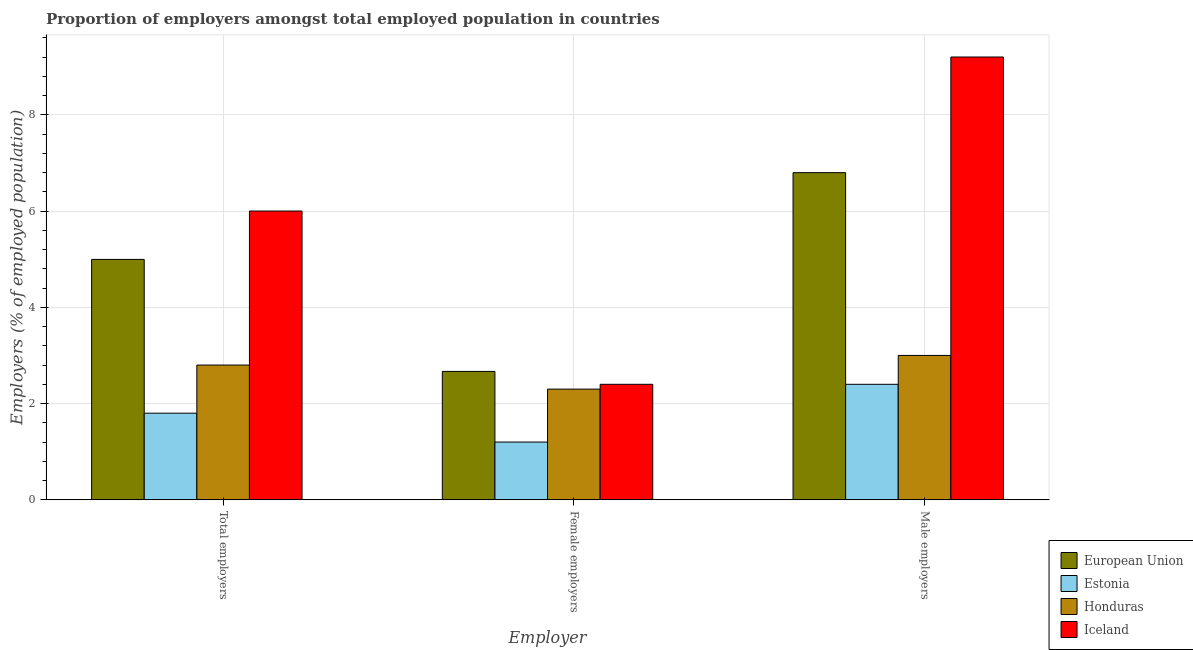How many different coloured bars are there?
Provide a succinct answer. 4. How many groups of bars are there?
Offer a very short reply. 3. How many bars are there on the 3rd tick from the left?
Your answer should be very brief. 4. How many bars are there on the 1st tick from the right?
Provide a succinct answer. 4. What is the label of the 2nd group of bars from the left?
Keep it short and to the point. Female employers. What is the percentage of female employers in Honduras?
Give a very brief answer. 2.3. Across all countries, what is the minimum percentage of female employers?
Keep it short and to the point. 1.2. In which country was the percentage of male employers maximum?
Keep it short and to the point. Iceland. In which country was the percentage of male employers minimum?
Provide a succinct answer. Estonia. What is the total percentage of female employers in the graph?
Your answer should be compact. 8.57. What is the difference between the percentage of male employers in Honduras and that in Iceland?
Offer a terse response. -6.2. What is the difference between the percentage of total employers in European Union and the percentage of female employers in Iceland?
Provide a short and direct response. 2.6. What is the average percentage of male employers per country?
Offer a terse response. 5.35. What is the difference between the percentage of female employers and percentage of male employers in Honduras?
Give a very brief answer. -0.7. In how many countries, is the percentage of total employers greater than 3.6 %?
Your answer should be very brief. 2. What is the ratio of the percentage of total employers in Honduras to that in Iceland?
Offer a terse response. 0.47. Is the difference between the percentage of total employers in Iceland and Estonia greater than the difference between the percentage of female employers in Iceland and Estonia?
Ensure brevity in your answer.  Yes. What is the difference between the highest and the second highest percentage of female employers?
Keep it short and to the point. 0.27. What is the difference between the highest and the lowest percentage of male employers?
Give a very brief answer. 6.8. Is the sum of the percentage of total employers in Iceland and Honduras greater than the maximum percentage of female employers across all countries?
Provide a short and direct response. Yes. What does the 4th bar from the left in Female employers represents?
Make the answer very short. Iceland. Are all the bars in the graph horizontal?
Provide a short and direct response. No. What is the difference between two consecutive major ticks on the Y-axis?
Provide a short and direct response. 2. Does the graph contain any zero values?
Provide a short and direct response. No. Where does the legend appear in the graph?
Your answer should be compact. Bottom right. How many legend labels are there?
Ensure brevity in your answer.  4. How are the legend labels stacked?
Your answer should be compact. Vertical. What is the title of the graph?
Your response must be concise. Proportion of employers amongst total employed population in countries. What is the label or title of the X-axis?
Your answer should be very brief. Employer. What is the label or title of the Y-axis?
Give a very brief answer. Employers (% of employed population). What is the Employers (% of employed population) in European Union in Total employers?
Keep it short and to the point. 5. What is the Employers (% of employed population) in Estonia in Total employers?
Give a very brief answer. 1.8. What is the Employers (% of employed population) in Honduras in Total employers?
Your response must be concise. 2.8. What is the Employers (% of employed population) of European Union in Female employers?
Give a very brief answer. 2.67. What is the Employers (% of employed population) in Estonia in Female employers?
Keep it short and to the point. 1.2. What is the Employers (% of employed population) of Honduras in Female employers?
Offer a very short reply. 2.3. What is the Employers (% of employed population) in Iceland in Female employers?
Your answer should be very brief. 2.4. What is the Employers (% of employed population) of European Union in Male employers?
Make the answer very short. 6.8. What is the Employers (% of employed population) in Estonia in Male employers?
Ensure brevity in your answer.  2.4. What is the Employers (% of employed population) of Honduras in Male employers?
Ensure brevity in your answer.  3. What is the Employers (% of employed population) in Iceland in Male employers?
Your response must be concise. 9.2. Across all Employer, what is the maximum Employers (% of employed population) in European Union?
Provide a succinct answer. 6.8. Across all Employer, what is the maximum Employers (% of employed population) of Estonia?
Provide a short and direct response. 2.4. Across all Employer, what is the maximum Employers (% of employed population) of Honduras?
Provide a succinct answer. 3. Across all Employer, what is the maximum Employers (% of employed population) in Iceland?
Provide a succinct answer. 9.2. Across all Employer, what is the minimum Employers (% of employed population) of European Union?
Offer a terse response. 2.67. Across all Employer, what is the minimum Employers (% of employed population) of Estonia?
Provide a succinct answer. 1.2. Across all Employer, what is the minimum Employers (% of employed population) in Honduras?
Provide a short and direct response. 2.3. Across all Employer, what is the minimum Employers (% of employed population) in Iceland?
Your answer should be very brief. 2.4. What is the total Employers (% of employed population) in European Union in the graph?
Provide a succinct answer. 14.46. What is the total Employers (% of employed population) of Estonia in the graph?
Your response must be concise. 5.4. What is the total Employers (% of employed population) in Honduras in the graph?
Offer a very short reply. 8.1. What is the difference between the Employers (% of employed population) in European Union in Total employers and that in Female employers?
Keep it short and to the point. 2.33. What is the difference between the Employers (% of employed population) in Iceland in Total employers and that in Female employers?
Offer a terse response. 3.6. What is the difference between the Employers (% of employed population) of European Union in Total employers and that in Male employers?
Give a very brief answer. -1.8. What is the difference between the Employers (% of employed population) of Estonia in Total employers and that in Male employers?
Give a very brief answer. -0.6. What is the difference between the Employers (% of employed population) of European Union in Female employers and that in Male employers?
Give a very brief answer. -4.13. What is the difference between the Employers (% of employed population) in Honduras in Female employers and that in Male employers?
Your answer should be compact. -0.7. What is the difference between the Employers (% of employed population) in European Union in Total employers and the Employers (% of employed population) in Estonia in Female employers?
Your answer should be compact. 3.8. What is the difference between the Employers (% of employed population) in European Union in Total employers and the Employers (% of employed population) in Honduras in Female employers?
Ensure brevity in your answer.  2.7. What is the difference between the Employers (% of employed population) in European Union in Total employers and the Employers (% of employed population) in Iceland in Female employers?
Your answer should be very brief. 2.6. What is the difference between the Employers (% of employed population) in Honduras in Total employers and the Employers (% of employed population) in Iceland in Female employers?
Offer a terse response. 0.4. What is the difference between the Employers (% of employed population) of European Union in Total employers and the Employers (% of employed population) of Estonia in Male employers?
Make the answer very short. 2.6. What is the difference between the Employers (% of employed population) of European Union in Total employers and the Employers (% of employed population) of Honduras in Male employers?
Offer a terse response. 2. What is the difference between the Employers (% of employed population) in European Union in Total employers and the Employers (% of employed population) in Iceland in Male employers?
Make the answer very short. -4.2. What is the difference between the Employers (% of employed population) in Estonia in Total employers and the Employers (% of employed population) in Honduras in Male employers?
Your response must be concise. -1.2. What is the difference between the Employers (% of employed population) of European Union in Female employers and the Employers (% of employed population) of Estonia in Male employers?
Make the answer very short. 0.27. What is the difference between the Employers (% of employed population) of European Union in Female employers and the Employers (% of employed population) of Honduras in Male employers?
Your answer should be very brief. -0.33. What is the difference between the Employers (% of employed population) of European Union in Female employers and the Employers (% of employed population) of Iceland in Male employers?
Offer a terse response. -6.53. What is the average Employers (% of employed population) in European Union per Employer?
Offer a very short reply. 4.82. What is the average Employers (% of employed population) of Estonia per Employer?
Make the answer very short. 1.8. What is the average Employers (% of employed population) in Honduras per Employer?
Your answer should be very brief. 2.7. What is the average Employers (% of employed population) of Iceland per Employer?
Provide a succinct answer. 5.87. What is the difference between the Employers (% of employed population) in European Union and Employers (% of employed population) in Estonia in Total employers?
Provide a short and direct response. 3.2. What is the difference between the Employers (% of employed population) of European Union and Employers (% of employed population) of Honduras in Total employers?
Give a very brief answer. 2.2. What is the difference between the Employers (% of employed population) of European Union and Employers (% of employed population) of Iceland in Total employers?
Provide a succinct answer. -1. What is the difference between the Employers (% of employed population) of Estonia and Employers (% of employed population) of Iceland in Total employers?
Offer a very short reply. -4.2. What is the difference between the Employers (% of employed population) in European Union and Employers (% of employed population) in Estonia in Female employers?
Make the answer very short. 1.47. What is the difference between the Employers (% of employed population) of European Union and Employers (% of employed population) of Honduras in Female employers?
Give a very brief answer. 0.37. What is the difference between the Employers (% of employed population) in European Union and Employers (% of employed population) in Iceland in Female employers?
Offer a terse response. 0.27. What is the difference between the Employers (% of employed population) in European Union and Employers (% of employed population) in Estonia in Male employers?
Your answer should be very brief. 4.4. What is the difference between the Employers (% of employed population) in European Union and Employers (% of employed population) in Honduras in Male employers?
Give a very brief answer. 3.8. What is the difference between the Employers (% of employed population) in European Union and Employers (% of employed population) in Iceland in Male employers?
Your response must be concise. -2.4. What is the difference between the Employers (% of employed population) of Estonia and Employers (% of employed population) of Iceland in Male employers?
Keep it short and to the point. -6.8. What is the ratio of the Employers (% of employed population) in European Union in Total employers to that in Female employers?
Your response must be concise. 1.87. What is the ratio of the Employers (% of employed population) in Estonia in Total employers to that in Female employers?
Offer a very short reply. 1.5. What is the ratio of the Employers (% of employed population) of Honduras in Total employers to that in Female employers?
Your answer should be compact. 1.22. What is the ratio of the Employers (% of employed population) of European Union in Total employers to that in Male employers?
Your response must be concise. 0.73. What is the ratio of the Employers (% of employed population) in Honduras in Total employers to that in Male employers?
Offer a very short reply. 0.93. What is the ratio of the Employers (% of employed population) of Iceland in Total employers to that in Male employers?
Provide a short and direct response. 0.65. What is the ratio of the Employers (% of employed population) in European Union in Female employers to that in Male employers?
Ensure brevity in your answer.  0.39. What is the ratio of the Employers (% of employed population) in Estonia in Female employers to that in Male employers?
Offer a terse response. 0.5. What is the ratio of the Employers (% of employed population) of Honduras in Female employers to that in Male employers?
Give a very brief answer. 0.77. What is the ratio of the Employers (% of employed population) in Iceland in Female employers to that in Male employers?
Provide a succinct answer. 0.26. What is the difference between the highest and the second highest Employers (% of employed population) of European Union?
Make the answer very short. 1.8. What is the difference between the highest and the second highest Employers (% of employed population) in Iceland?
Provide a succinct answer. 3.2. What is the difference between the highest and the lowest Employers (% of employed population) of European Union?
Keep it short and to the point. 4.13. What is the difference between the highest and the lowest Employers (% of employed population) of Estonia?
Ensure brevity in your answer.  1.2. What is the difference between the highest and the lowest Employers (% of employed population) of Honduras?
Your response must be concise. 0.7. 